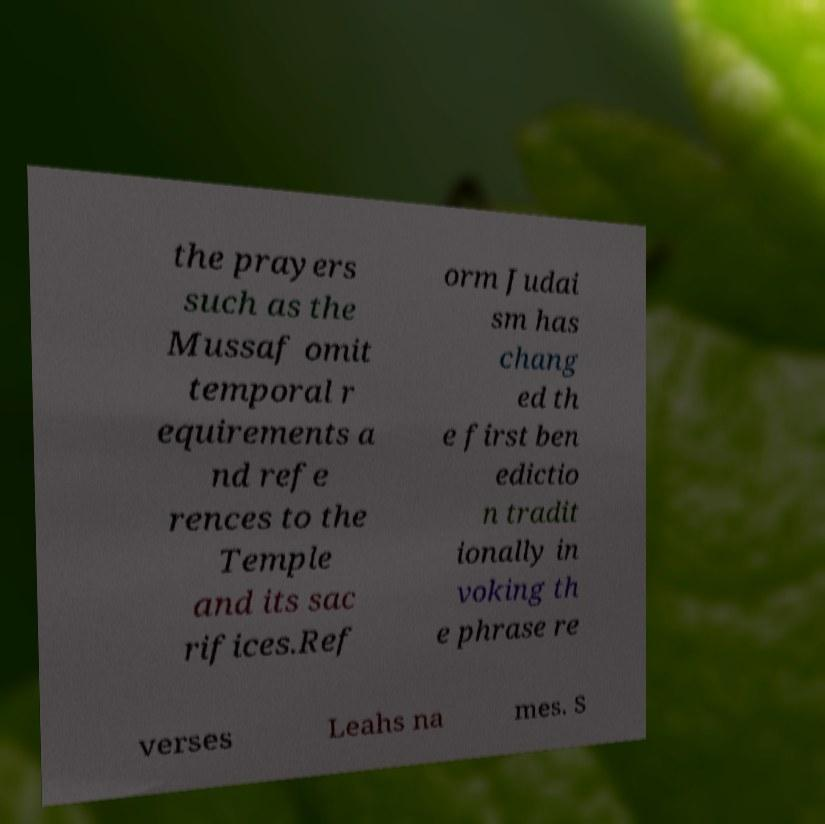Please identify and transcribe the text found in this image. the prayers such as the Mussaf omit temporal r equirements a nd refe rences to the Temple and its sac rifices.Ref orm Judai sm has chang ed th e first ben edictio n tradit ionally in voking th e phrase re verses Leahs na mes. S 